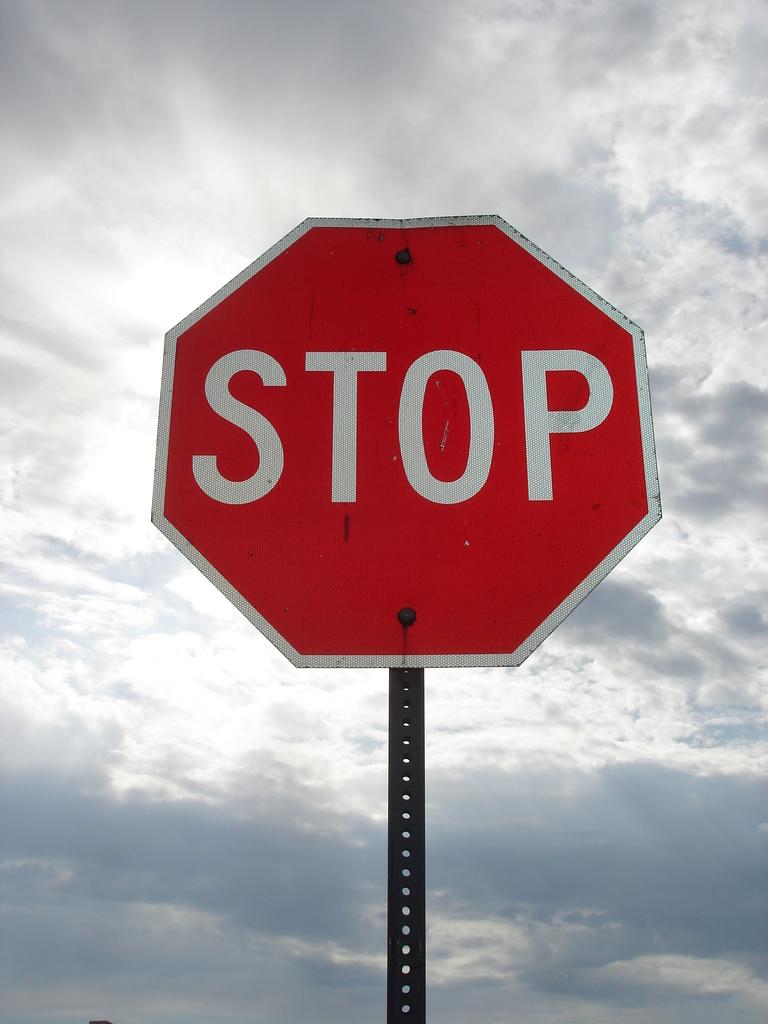What does this sign say?
Keep it short and to the point. Stop. How many letters are on this sign?
Provide a succinct answer. 4. 